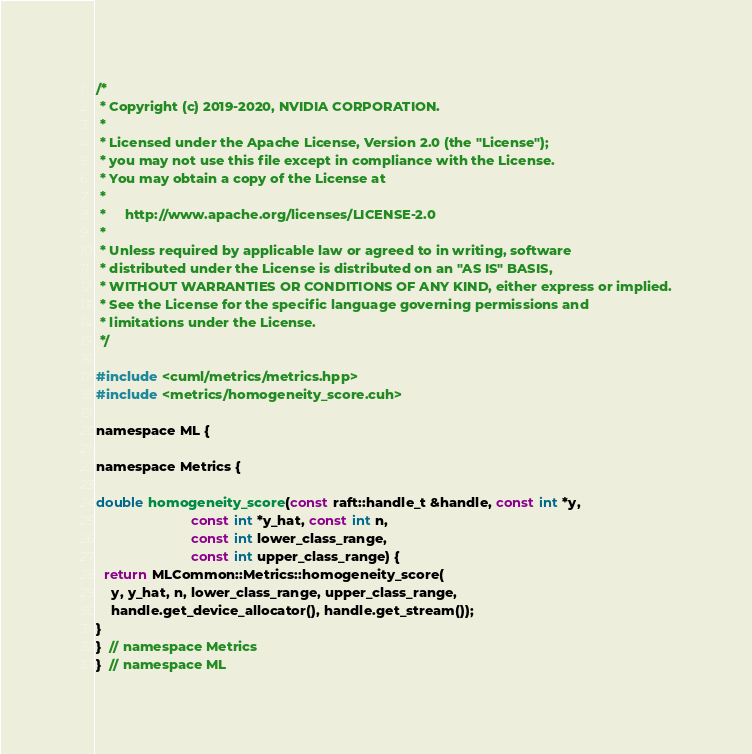Convert code to text. <code><loc_0><loc_0><loc_500><loc_500><_Cuda_>
/*
 * Copyright (c) 2019-2020, NVIDIA CORPORATION.
 *
 * Licensed under the Apache License, Version 2.0 (the "License");
 * you may not use this file except in compliance with the License.
 * You may obtain a copy of the License at
 *
 *     http://www.apache.org/licenses/LICENSE-2.0
 *
 * Unless required by applicable law or agreed to in writing, software
 * distributed under the License is distributed on an "AS IS" BASIS,
 * WITHOUT WARRANTIES OR CONDITIONS OF ANY KIND, either express or implied.
 * See the License for the specific language governing permissions and
 * limitations under the License.
 */

#include <cuml/metrics/metrics.hpp>
#include <metrics/homogeneity_score.cuh>

namespace ML {

namespace Metrics {

double homogeneity_score(const raft::handle_t &handle, const int *y,
                         const int *y_hat, const int n,
                         const int lower_class_range,
                         const int upper_class_range) {
  return MLCommon::Metrics::homogeneity_score(
    y, y_hat, n, lower_class_range, upper_class_range,
    handle.get_device_allocator(), handle.get_stream());
}
}  // namespace Metrics
}  // namespace ML
</code> 